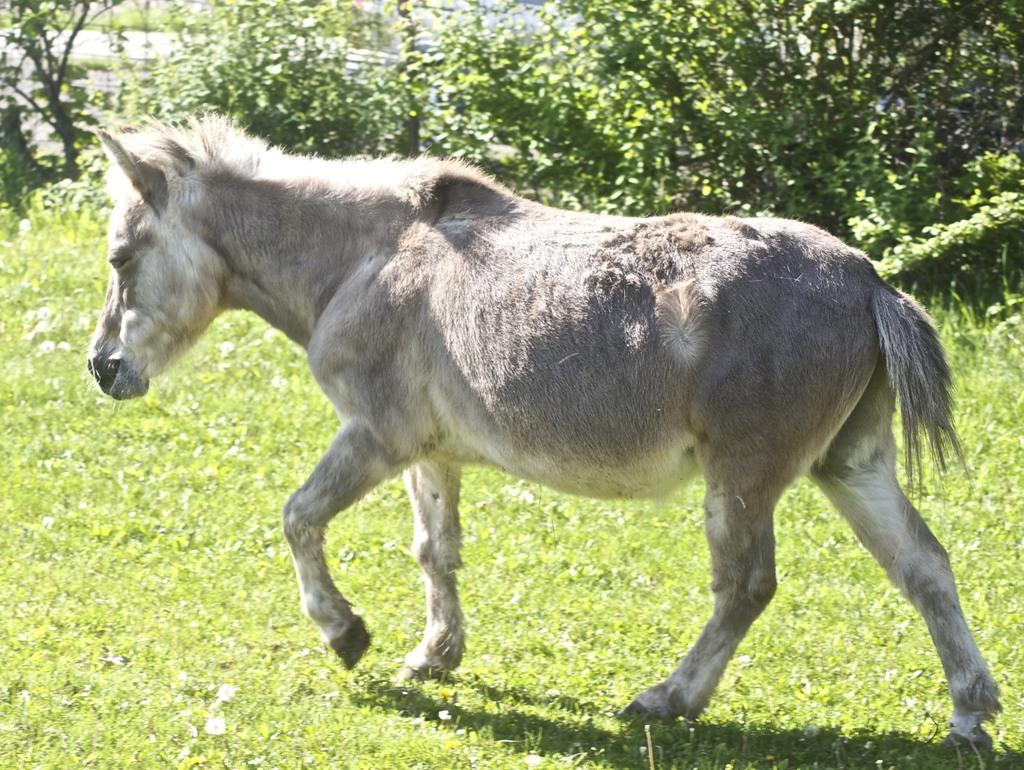What animal is present in the image? There is a donkey in the image. What is the donkey doing in the image? The donkey is walking in the image. What type of vegetation can be seen in the image? There is grass visible in the image. What type of plants are present in the image? There are trees with branches and leaves in the image. What type of club does the laborer use to shame the donkey in the image? There is no laborer, club, or any indication of shaming in the image; it features a donkey walking in a grassy area with trees. 